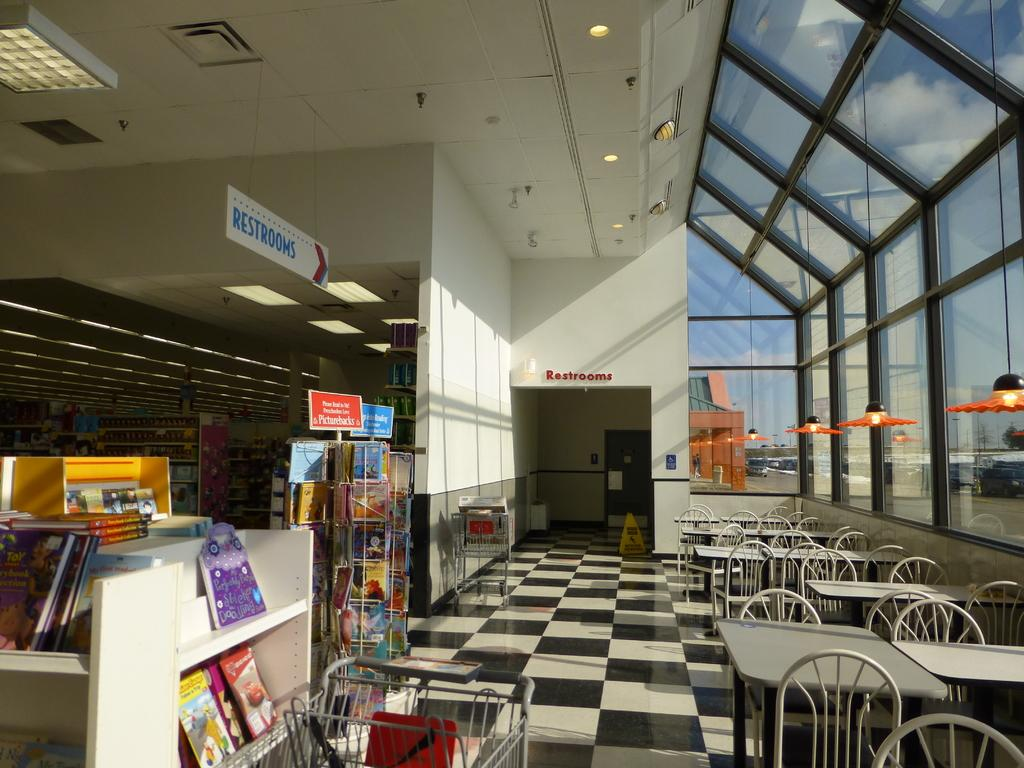Provide a one-sentence caption for the provided image. a sign above the books that has restrooms on it. 